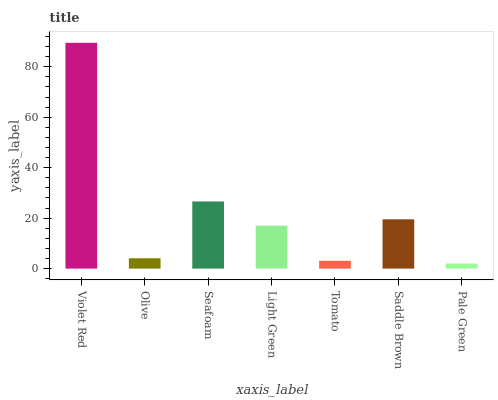Is Pale Green the minimum?
Answer yes or no. Yes. Is Violet Red the maximum?
Answer yes or no. Yes. Is Olive the minimum?
Answer yes or no. No. Is Olive the maximum?
Answer yes or no. No. Is Violet Red greater than Olive?
Answer yes or no. Yes. Is Olive less than Violet Red?
Answer yes or no. Yes. Is Olive greater than Violet Red?
Answer yes or no. No. Is Violet Red less than Olive?
Answer yes or no. No. Is Light Green the high median?
Answer yes or no. Yes. Is Light Green the low median?
Answer yes or no. Yes. Is Saddle Brown the high median?
Answer yes or no. No. Is Violet Red the low median?
Answer yes or no. No. 